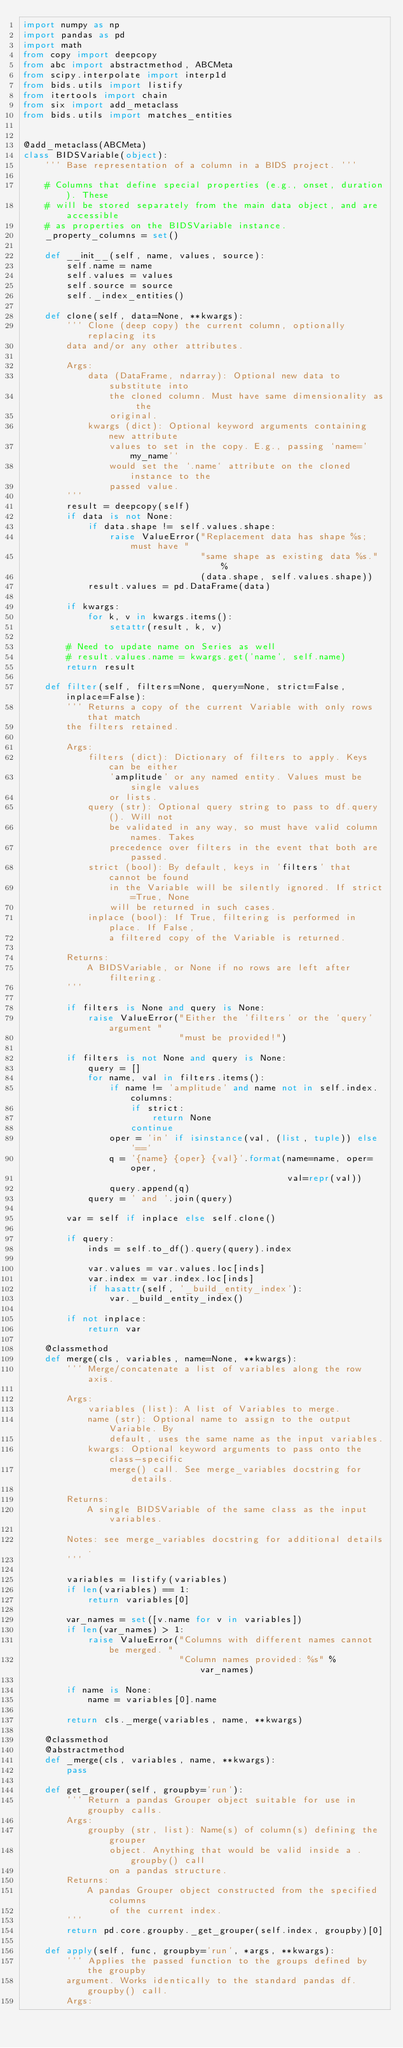Convert code to text. <code><loc_0><loc_0><loc_500><loc_500><_Python_>import numpy as np
import pandas as pd
import math
from copy import deepcopy
from abc import abstractmethod, ABCMeta
from scipy.interpolate import interp1d
from bids.utils import listify
from itertools import chain
from six import add_metaclass
from bids.utils import matches_entities


@add_metaclass(ABCMeta)
class BIDSVariable(object):
    ''' Base representation of a column in a BIDS project. '''

    # Columns that define special properties (e.g., onset, duration). These
    # will be stored separately from the main data object, and are accessible
    # as properties on the BIDSVariable instance.
    _property_columns = set()

    def __init__(self, name, values, source):
        self.name = name
        self.values = values
        self.source = source
        self._index_entities()

    def clone(self, data=None, **kwargs):
        ''' Clone (deep copy) the current column, optionally replacing its
        data and/or any other attributes.

        Args:
            data (DataFrame, ndarray): Optional new data to substitute into
                the cloned column. Must have same dimensionality as the
                original.
            kwargs (dict): Optional keyword arguments containing new attribute
                values to set in the copy. E.g., passing `name='my_name'`
                would set the `.name` attribute on the cloned instance to the
                passed value.
        '''
        result = deepcopy(self)
        if data is not None:
            if data.shape != self.values.shape:
                raise ValueError("Replacement data has shape %s; must have "
                                 "same shape as existing data %s." %
                                 (data.shape, self.values.shape))
            result.values = pd.DataFrame(data)

        if kwargs:
            for k, v in kwargs.items():
                setattr(result, k, v)

        # Need to update name on Series as well
        # result.values.name = kwargs.get('name', self.name)
        return result

    def filter(self, filters=None, query=None, strict=False, inplace=False):
        ''' Returns a copy of the current Variable with only rows that match
        the filters retained.

        Args:
            filters (dict): Dictionary of filters to apply. Keys can be either
                'amplitude' or any named entity. Values must be single values
                or lists.
            query (str): Optional query string to pass to df.query(). Will not
                be validated in any way, so must have valid column names. Takes
                precedence over filters in the event that both are passed.
            strict (bool): By default, keys in 'filters' that cannot be found
                in the Variable will be silently ignored. If strict=True, None
                will be returned in such cases.
            inplace (bool): If True, filtering is performed in place. If False,
                a filtered copy of the Variable is returned.

        Returns:
            A BIDSVariable, or None if no rows are left after filtering.
        '''

        if filters is None and query is None:
            raise ValueError("Either the 'filters' or the 'query' argument "
                             "must be provided!")

        if filters is not None and query is None:
            query = []
            for name, val in filters.items():
                if name != 'amplitude' and name not in self.index.columns:
                    if strict:
                        return None
                    continue
                oper = 'in' if isinstance(val, (list, tuple)) else '=='
                q = '{name} {oper} {val}'.format(name=name, oper=oper,
                                                 val=repr(val))
                query.append(q)
            query = ' and '.join(query)

        var = self if inplace else self.clone()

        if query:
            inds = self.to_df().query(query).index

            var.values = var.values.loc[inds]
            var.index = var.index.loc[inds]
            if hasattr(self, '_build_entity_index'):
                var._build_entity_index()

        if not inplace:
            return var

    @classmethod
    def merge(cls, variables, name=None, **kwargs):
        ''' Merge/concatenate a list of variables along the row axis.

        Args:
            variables (list): A list of Variables to merge.
            name (str): Optional name to assign to the output Variable. By
                default, uses the same name as the input variables.
            kwargs: Optional keyword arguments to pass onto the class-specific
                merge() call. See merge_variables docstring for details.

        Returns:
            A single BIDSVariable of the same class as the input variables.

        Notes: see merge_variables docstring for additional details.
        '''

        variables = listify(variables)
        if len(variables) == 1:
            return variables[0]

        var_names = set([v.name for v in variables])
        if len(var_names) > 1:
            raise ValueError("Columns with different names cannot be merged. "
                             "Column names provided: %s" % var_names)

        if name is None:
            name = variables[0].name

        return cls._merge(variables, name, **kwargs)

    @classmethod
    @abstractmethod
    def _merge(cls, variables, name, **kwargs):
        pass

    def get_grouper(self, groupby='run'):
        ''' Return a pandas Grouper object suitable for use in groupby calls.
        Args:
            groupby (str, list): Name(s) of column(s) defining the grouper
                object. Anything that would be valid inside a .groupby() call
                on a pandas structure.
        Returns:
            A pandas Grouper object constructed from the specified columns
                of the current index.
        '''
        return pd.core.groupby._get_grouper(self.index, groupby)[0]

    def apply(self, func, groupby='run', *args, **kwargs):
        ''' Applies the passed function to the groups defined by the groupby
        argument. Works identically to the standard pandas df.groupby() call.
        Args:</code> 